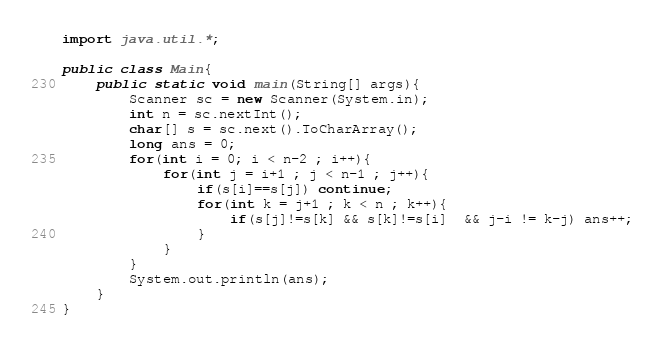Convert code to text. <code><loc_0><loc_0><loc_500><loc_500><_Java_>import java.util.*;
 
public class Main{
	public static void main(String[] args){
    	Scanner sc = new Scanner(System.in);
      	int n = sc.nextInt();
      	char[] s = sc.next().ToCharArray();
      	long ans = 0;
      	for(int i = 0; i < n-2 ; i++){
        	for(int j = i+1 ; j < n-1 ; j++){
              	if(s[i]==s[j]) continue;
              	for(int k = j+1 ; k < n ; k++){
                 	if(s[j]!=s[k] && s[k]!=s[i]  && j-i != k-j) ans++;
                }
            }
        }
      	System.out.println(ans);
    }
}</code> 